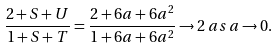Convert formula to latex. <formula><loc_0><loc_0><loc_500><loc_500>\frac { 2 + S + U } { 1 + S + T } = \frac { 2 + 6 a + 6 a ^ { 2 } } { 1 + 6 a + 6 a ^ { 2 } } \rightarrow 2 \, { a s } \, a \rightarrow 0 .</formula> 